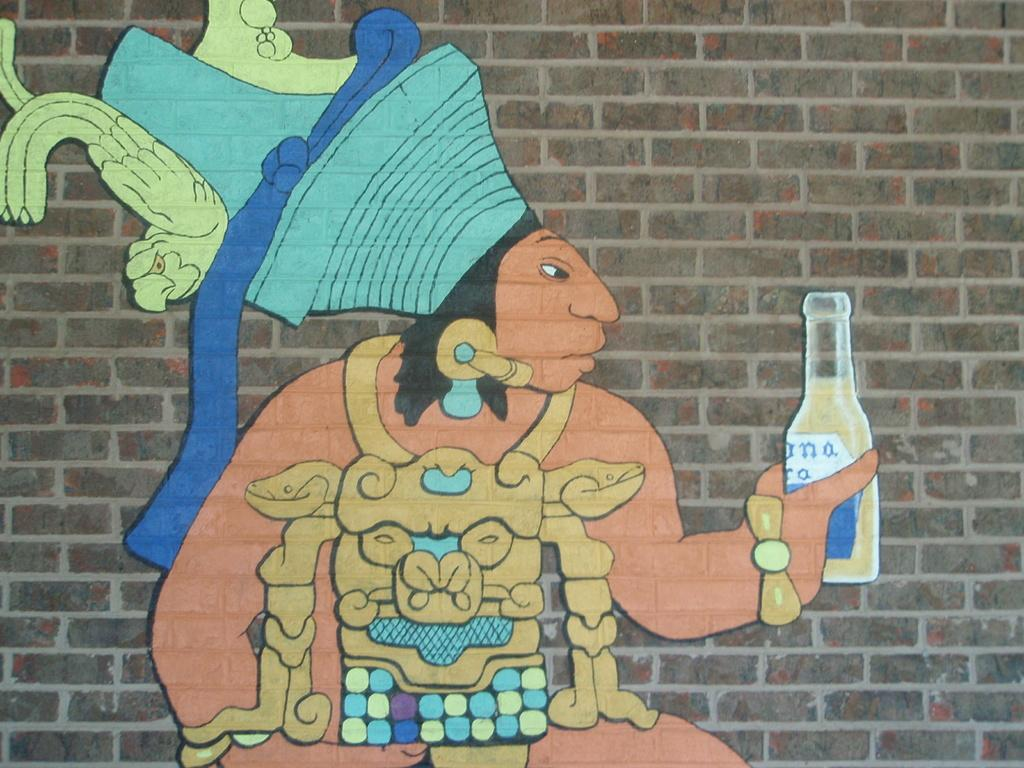<image>
Render a clear and concise summary of the photo. A painting of a Native American holding a Corona beer. 